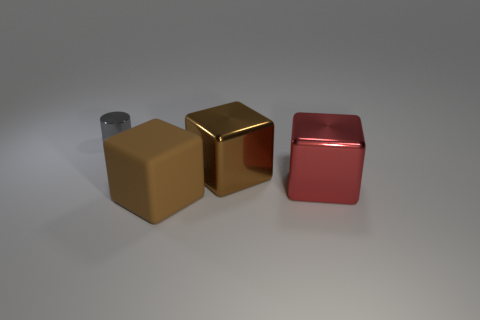Subtract all red cylinders. How many brown cubes are left? 2 Subtract all brown blocks. How many blocks are left? 1 Add 3 brown matte things. How many objects exist? 7 Subtract all cylinders. How many objects are left? 3 Add 1 yellow spheres. How many yellow spheres exist? 1 Subtract 0 purple cylinders. How many objects are left? 4 Subtract all shiny things. Subtract all big yellow metal balls. How many objects are left? 1 Add 1 gray metallic cylinders. How many gray metallic cylinders are left? 2 